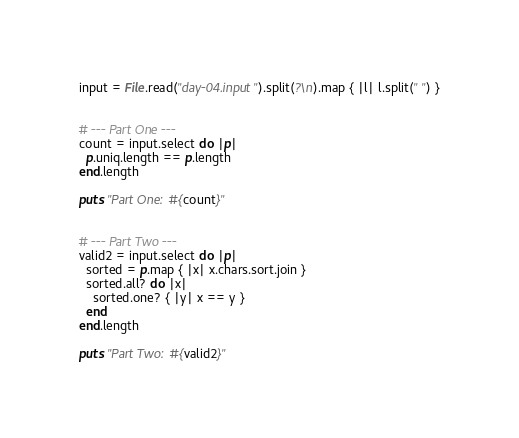Convert code to text. <code><loc_0><loc_0><loc_500><loc_500><_Ruby_>input = File.read("day-04.input").split(?\n).map { |l| l.split(" ") }


# --- Part One ---
count = input.select do |p|
  p.uniq.length == p.length
end.length

puts "Part One: #{count}"


# --- Part Two ---
valid2 = input.select do |p|
  sorted = p.map { |x| x.chars.sort.join }
  sorted.all? do |x|
    sorted.one? { |y| x == y }
  end
end.length

puts "Part Two: #{valid2}"
</code> 